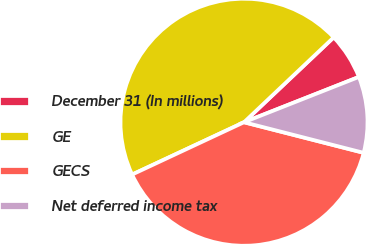Convert chart. <chart><loc_0><loc_0><loc_500><loc_500><pie_chart><fcel>December 31 (In millions)<fcel>GE<fcel>GECS<fcel>Net deferred income tax<nl><fcel>6.08%<fcel>44.9%<fcel>39.06%<fcel>9.96%<nl></chart> 